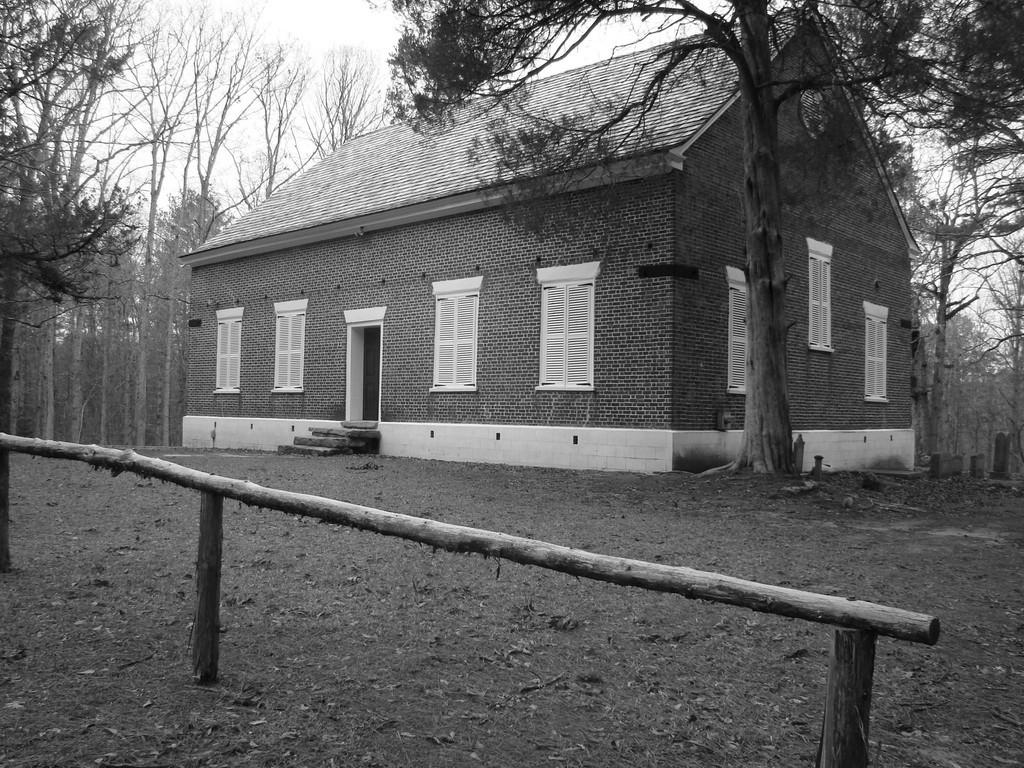What type of structure is visible in the image? There is a house in the image. What other natural elements can be seen in the image? There are trees in the image. What is the wooden object on the ground? The wooden object on the ground is not specified in the facts. What is visible in the background of the image? The sky is visible in the background of the image. What is the color scheme of the image? The image is black and white in color. What type of apple is hanging from the tree in the image? There is no apple present in the image; it is a black and white image with no visible fruit. 